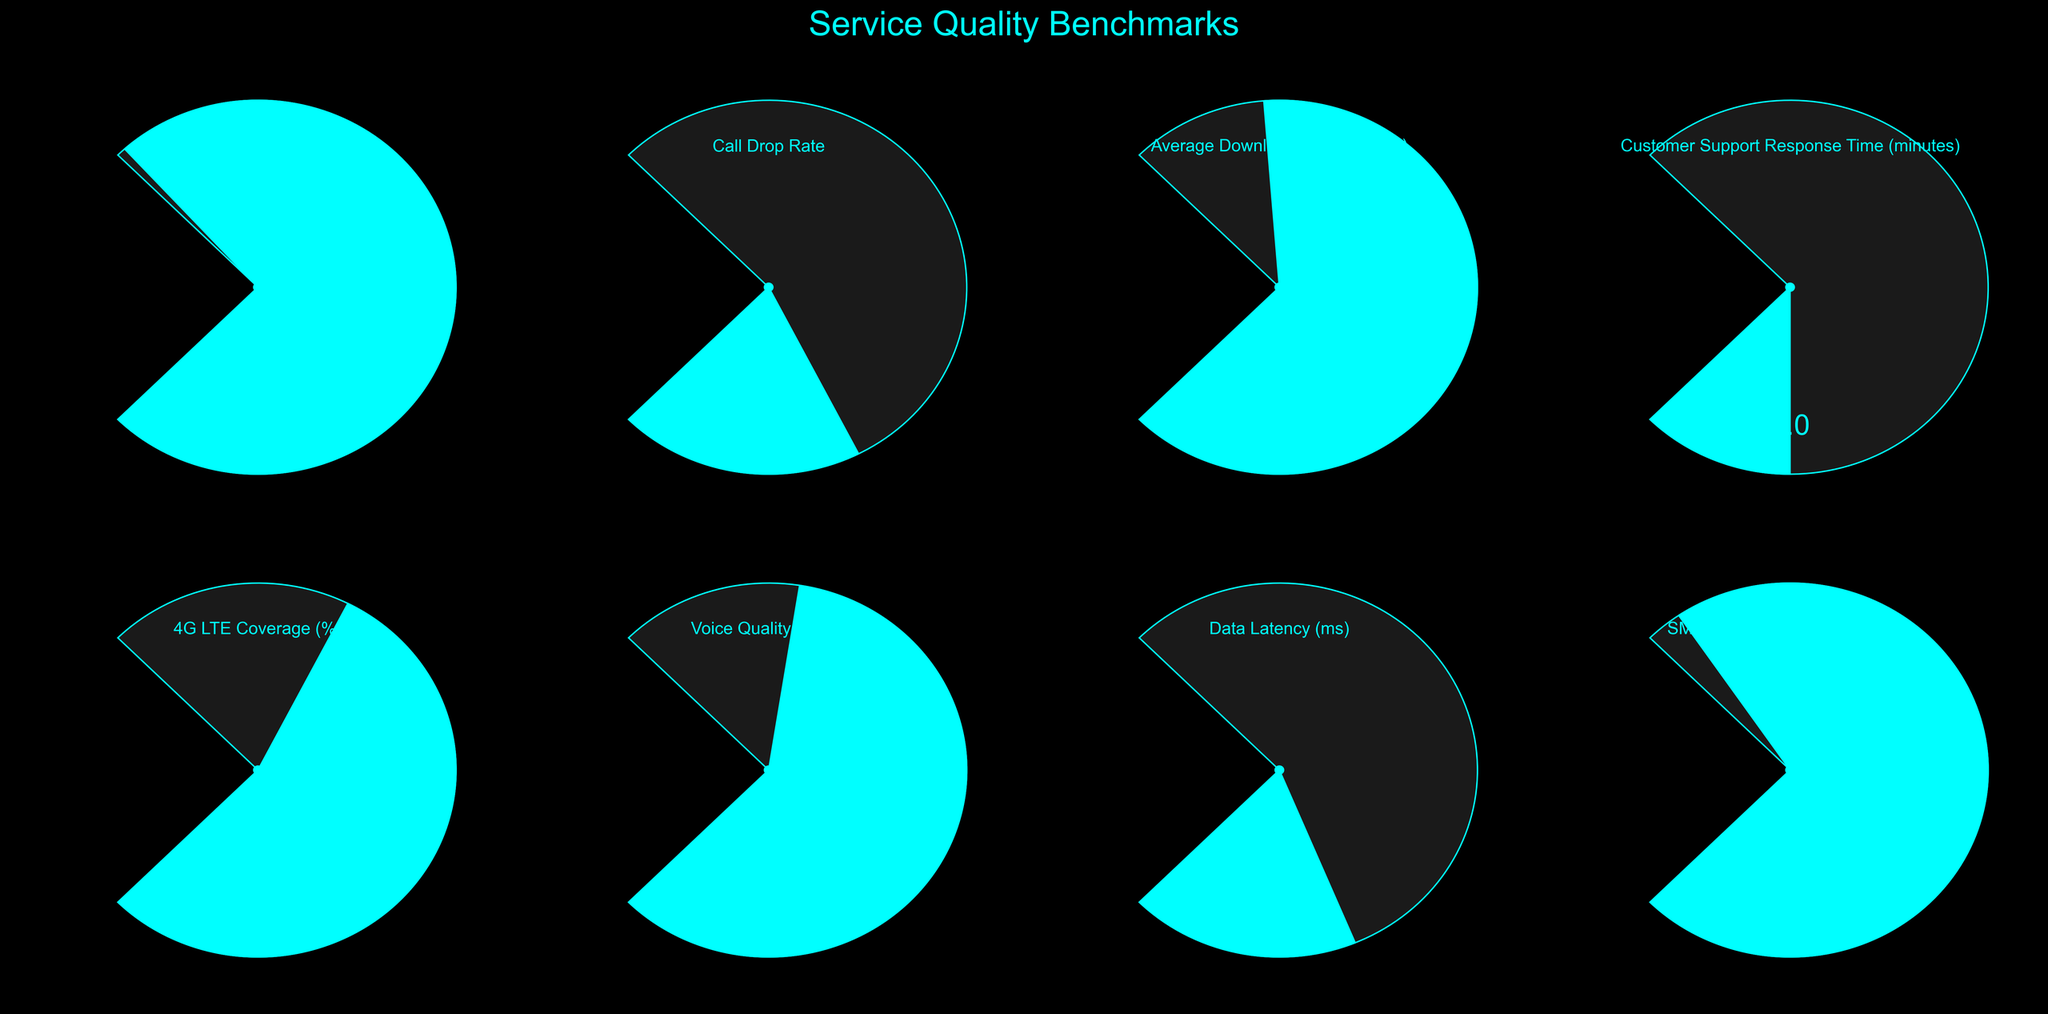What is the overall title of the figure? The title of the figure can be found at the top, indicating the theme or context. In this case, it is displayed in large and bold font.
Answer: Service Quality Benchmarks What is the value for Network Availability? The value for Network Availability can be seen in the gauge labeled "Network Availability", where the needle points to a number within the gauge.
Answer: 99.95 Which benchmark has the worst (highest) value for Call Drop Rate? The gauge for Call Drop Rate shows its value, which is visually represented as 0.8%. This is the highest value for Call Drop Rate in comparison to the rest.
Answer: 0.8 Compare the Average Download Speed and Data Latency values. Which one is closer to the maximum of its range? For Average Download Speed, the value is 85 Mbps with a maximum range of 100 Mbps, and for Data Latency, the value is 25 ms with a maximum range of 100 ms. Therefore, 85 Mbps is closer to 100 Mbps than 25 ms is to 100 ms.
Answer: Average Download Speed What is the percentage of 4G LTE Coverage? The percentage of 4G LTE Coverage can be directly read from the corresponding gauge, which is labeled "4G LTE Coverage".
Answer: 92% Which service quality benchmark has the lowest (best) Customer Support Response Time? The gauge for Customer Support Response Time shows the value as 5 minutes, which can be seen visually on the chart.
Answer: 5 minutes Is the SMS Delivery Success Rate above 99.5%? The gauge for SMS Delivery Success Rate shows a value of 99.8%, which is visually higher than 99.5%.
Answer: Yes What is the difference between Voice Quality (MOS) and Call Drop Rate values? The value for Voice Quality (MOS) is 4.2, and for Call Drop Rate, it is 0.8. Subtracting the Call Drop Rate from the Voice Quality gives the difference.
Answer: 3.4 Which benchmark has a value equal to 99.8%? The specific benchmark with a value of 99.8% can be identified by looking through each gauge and identifying the one with this value. It is labeled as SMS Delivery Success Rate.
Answer: SMS Delivery Success Rate How does Customer Support Response Time compare to Data Latency? The value for Customer Support Response Time is 5 minutes, and for Data Latency, it is 25 ms. Comparing these two values shows that Customer Support Response Time is less by numerical value.
Answer: Customer Support Response Time is higher in value but in a different unit (minutes vs milliseconds) 